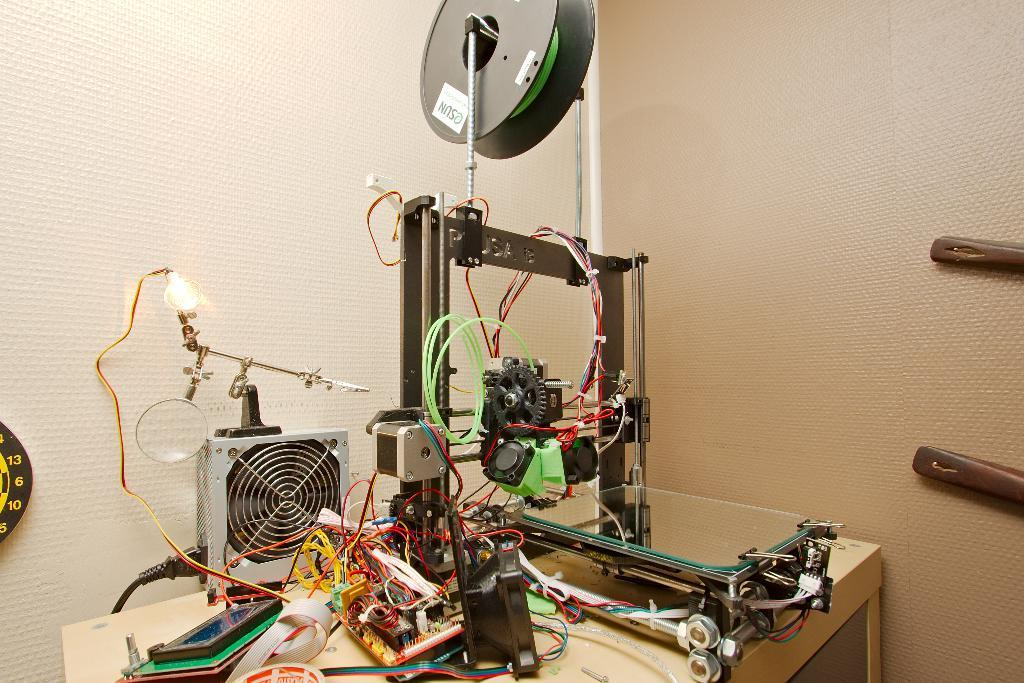What type of object is the main subject in the image? There is an electrical equipment in the image. Where is the electrical equipment located? The electrical equipment is placed on a table. What can be seen in the background of the image? There is a wall in the background of the image. How many eggs are being produced by the air in the image? There is no air or egg production present in the image; it features an electrical equipment placed on a table with a wall in the background. 